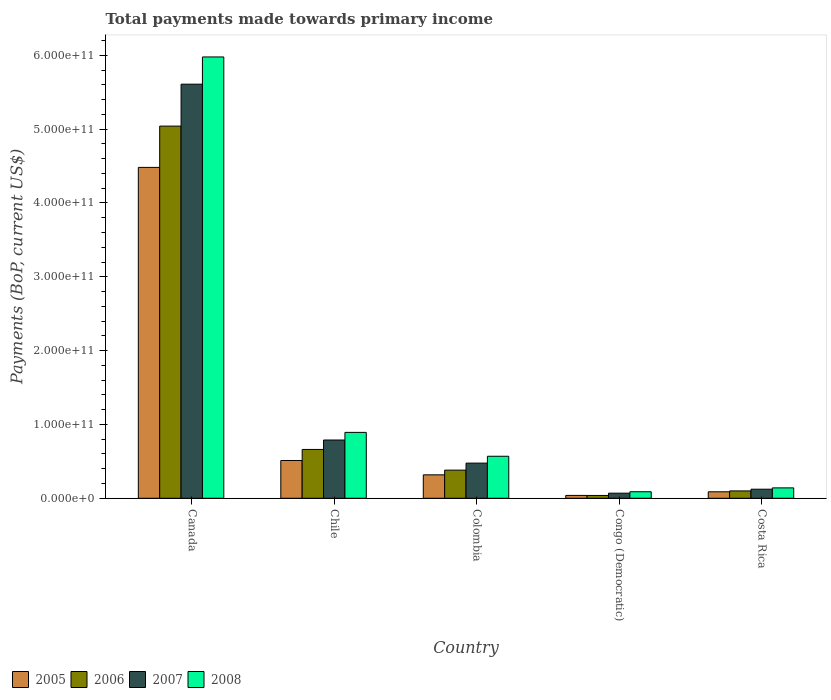How many groups of bars are there?
Provide a succinct answer. 5. Are the number of bars per tick equal to the number of legend labels?
Make the answer very short. Yes. Are the number of bars on each tick of the X-axis equal?
Provide a short and direct response. Yes. In how many cases, is the number of bars for a given country not equal to the number of legend labels?
Provide a succinct answer. 0. What is the total payments made towards primary income in 2007 in Colombia?
Make the answer very short. 4.76e+1. Across all countries, what is the maximum total payments made towards primary income in 2007?
Your answer should be compact. 5.61e+11. Across all countries, what is the minimum total payments made towards primary income in 2005?
Your answer should be compact. 3.89e+09. In which country was the total payments made towards primary income in 2007 minimum?
Keep it short and to the point. Congo (Democratic). What is the total total payments made towards primary income in 2007 in the graph?
Your response must be concise. 7.07e+11. What is the difference between the total payments made towards primary income in 2006 in Canada and that in Colombia?
Give a very brief answer. 4.66e+11. What is the difference between the total payments made towards primary income in 2006 in Costa Rica and the total payments made towards primary income in 2008 in Canada?
Your answer should be very brief. -5.88e+11. What is the average total payments made towards primary income in 2006 per country?
Your response must be concise. 1.24e+11. What is the difference between the total payments made towards primary income of/in 2007 and total payments made towards primary income of/in 2008 in Congo (Democratic)?
Offer a very short reply. -1.96e+09. In how many countries, is the total payments made towards primary income in 2005 greater than 380000000000 US$?
Offer a very short reply. 1. What is the ratio of the total payments made towards primary income in 2006 in Canada to that in Congo (Democratic)?
Ensure brevity in your answer.  131.65. What is the difference between the highest and the second highest total payments made towards primary income in 2005?
Ensure brevity in your answer.  -4.16e+11. What is the difference between the highest and the lowest total payments made towards primary income in 2008?
Make the answer very short. 5.89e+11. What does the 4th bar from the right in Costa Rica represents?
Your answer should be compact. 2005. How many countries are there in the graph?
Ensure brevity in your answer.  5. What is the difference between two consecutive major ticks on the Y-axis?
Make the answer very short. 1.00e+11. Where does the legend appear in the graph?
Your answer should be compact. Bottom left. How are the legend labels stacked?
Your answer should be very brief. Horizontal. What is the title of the graph?
Ensure brevity in your answer.  Total payments made towards primary income. Does "1977" appear as one of the legend labels in the graph?
Offer a terse response. No. What is the label or title of the Y-axis?
Offer a very short reply. Payments (BoP, current US$). What is the Payments (BoP, current US$) in 2005 in Canada?
Offer a terse response. 4.48e+11. What is the Payments (BoP, current US$) in 2006 in Canada?
Keep it short and to the point. 5.04e+11. What is the Payments (BoP, current US$) of 2007 in Canada?
Give a very brief answer. 5.61e+11. What is the Payments (BoP, current US$) in 2008 in Canada?
Your answer should be very brief. 5.98e+11. What is the Payments (BoP, current US$) of 2005 in Chile?
Offer a very short reply. 5.12e+1. What is the Payments (BoP, current US$) of 2006 in Chile?
Give a very brief answer. 6.61e+1. What is the Payments (BoP, current US$) in 2007 in Chile?
Your answer should be very brief. 7.89e+1. What is the Payments (BoP, current US$) in 2008 in Chile?
Your answer should be compact. 8.92e+1. What is the Payments (BoP, current US$) in 2005 in Colombia?
Your response must be concise. 3.18e+1. What is the Payments (BoP, current US$) of 2006 in Colombia?
Offer a very short reply. 3.81e+1. What is the Payments (BoP, current US$) in 2007 in Colombia?
Make the answer very short. 4.76e+1. What is the Payments (BoP, current US$) of 2008 in Colombia?
Ensure brevity in your answer.  5.69e+1. What is the Payments (BoP, current US$) of 2005 in Congo (Democratic)?
Your response must be concise. 3.89e+09. What is the Payments (BoP, current US$) in 2006 in Congo (Democratic)?
Your answer should be compact. 3.83e+09. What is the Payments (BoP, current US$) in 2007 in Congo (Democratic)?
Provide a succinct answer. 6.90e+09. What is the Payments (BoP, current US$) in 2008 in Congo (Democratic)?
Ensure brevity in your answer.  8.86e+09. What is the Payments (BoP, current US$) of 2005 in Costa Rica?
Keep it short and to the point. 8.79e+09. What is the Payments (BoP, current US$) of 2006 in Costa Rica?
Ensure brevity in your answer.  9.98e+09. What is the Payments (BoP, current US$) in 2007 in Costa Rica?
Give a very brief answer. 1.23e+1. What is the Payments (BoP, current US$) in 2008 in Costa Rica?
Ensure brevity in your answer.  1.41e+1. Across all countries, what is the maximum Payments (BoP, current US$) in 2005?
Provide a short and direct response. 4.48e+11. Across all countries, what is the maximum Payments (BoP, current US$) in 2006?
Ensure brevity in your answer.  5.04e+11. Across all countries, what is the maximum Payments (BoP, current US$) of 2007?
Provide a succinct answer. 5.61e+11. Across all countries, what is the maximum Payments (BoP, current US$) of 2008?
Ensure brevity in your answer.  5.98e+11. Across all countries, what is the minimum Payments (BoP, current US$) in 2005?
Make the answer very short. 3.89e+09. Across all countries, what is the minimum Payments (BoP, current US$) in 2006?
Give a very brief answer. 3.83e+09. Across all countries, what is the minimum Payments (BoP, current US$) in 2007?
Make the answer very short. 6.90e+09. Across all countries, what is the minimum Payments (BoP, current US$) in 2008?
Provide a succinct answer. 8.86e+09. What is the total Payments (BoP, current US$) in 2005 in the graph?
Give a very brief answer. 5.44e+11. What is the total Payments (BoP, current US$) in 2006 in the graph?
Give a very brief answer. 6.22e+11. What is the total Payments (BoP, current US$) in 2007 in the graph?
Keep it short and to the point. 7.07e+11. What is the total Payments (BoP, current US$) in 2008 in the graph?
Ensure brevity in your answer.  7.67e+11. What is the difference between the Payments (BoP, current US$) of 2005 in Canada and that in Chile?
Your answer should be compact. 3.97e+11. What is the difference between the Payments (BoP, current US$) of 2006 in Canada and that in Chile?
Make the answer very short. 4.38e+11. What is the difference between the Payments (BoP, current US$) in 2007 in Canada and that in Chile?
Your answer should be very brief. 4.82e+11. What is the difference between the Payments (BoP, current US$) in 2008 in Canada and that in Chile?
Offer a terse response. 5.09e+11. What is the difference between the Payments (BoP, current US$) of 2005 in Canada and that in Colombia?
Ensure brevity in your answer.  4.16e+11. What is the difference between the Payments (BoP, current US$) of 2006 in Canada and that in Colombia?
Your answer should be compact. 4.66e+11. What is the difference between the Payments (BoP, current US$) in 2007 in Canada and that in Colombia?
Your answer should be compact. 5.13e+11. What is the difference between the Payments (BoP, current US$) in 2008 in Canada and that in Colombia?
Keep it short and to the point. 5.41e+11. What is the difference between the Payments (BoP, current US$) in 2005 in Canada and that in Congo (Democratic)?
Ensure brevity in your answer.  4.44e+11. What is the difference between the Payments (BoP, current US$) of 2006 in Canada and that in Congo (Democratic)?
Offer a terse response. 5.00e+11. What is the difference between the Payments (BoP, current US$) in 2007 in Canada and that in Congo (Democratic)?
Offer a terse response. 5.54e+11. What is the difference between the Payments (BoP, current US$) of 2008 in Canada and that in Congo (Democratic)?
Provide a succinct answer. 5.89e+11. What is the difference between the Payments (BoP, current US$) in 2005 in Canada and that in Costa Rica?
Offer a terse response. 4.39e+11. What is the difference between the Payments (BoP, current US$) in 2006 in Canada and that in Costa Rica?
Give a very brief answer. 4.94e+11. What is the difference between the Payments (BoP, current US$) of 2007 in Canada and that in Costa Rica?
Keep it short and to the point. 5.49e+11. What is the difference between the Payments (BoP, current US$) of 2008 in Canada and that in Costa Rica?
Offer a terse response. 5.84e+11. What is the difference between the Payments (BoP, current US$) in 2005 in Chile and that in Colombia?
Ensure brevity in your answer.  1.94e+1. What is the difference between the Payments (BoP, current US$) in 2006 in Chile and that in Colombia?
Keep it short and to the point. 2.80e+1. What is the difference between the Payments (BoP, current US$) of 2007 in Chile and that in Colombia?
Provide a succinct answer. 3.13e+1. What is the difference between the Payments (BoP, current US$) of 2008 in Chile and that in Colombia?
Make the answer very short. 3.23e+1. What is the difference between the Payments (BoP, current US$) in 2005 in Chile and that in Congo (Democratic)?
Give a very brief answer. 4.73e+1. What is the difference between the Payments (BoP, current US$) of 2006 in Chile and that in Congo (Democratic)?
Make the answer very short. 6.23e+1. What is the difference between the Payments (BoP, current US$) in 2007 in Chile and that in Congo (Democratic)?
Offer a very short reply. 7.20e+1. What is the difference between the Payments (BoP, current US$) of 2008 in Chile and that in Congo (Democratic)?
Provide a succinct answer. 8.04e+1. What is the difference between the Payments (BoP, current US$) of 2005 in Chile and that in Costa Rica?
Keep it short and to the point. 4.24e+1. What is the difference between the Payments (BoP, current US$) in 2006 in Chile and that in Costa Rica?
Your answer should be compact. 5.62e+1. What is the difference between the Payments (BoP, current US$) in 2007 in Chile and that in Costa Rica?
Keep it short and to the point. 6.66e+1. What is the difference between the Payments (BoP, current US$) in 2008 in Chile and that in Costa Rica?
Provide a succinct answer. 7.52e+1. What is the difference between the Payments (BoP, current US$) in 2005 in Colombia and that in Congo (Democratic)?
Ensure brevity in your answer.  2.79e+1. What is the difference between the Payments (BoP, current US$) in 2006 in Colombia and that in Congo (Democratic)?
Offer a terse response. 3.43e+1. What is the difference between the Payments (BoP, current US$) of 2007 in Colombia and that in Congo (Democratic)?
Make the answer very short. 4.07e+1. What is the difference between the Payments (BoP, current US$) of 2008 in Colombia and that in Congo (Democratic)?
Offer a terse response. 4.81e+1. What is the difference between the Payments (BoP, current US$) in 2005 in Colombia and that in Costa Rica?
Offer a terse response. 2.30e+1. What is the difference between the Payments (BoP, current US$) of 2006 in Colombia and that in Costa Rica?
Give a very brief answer. 2.81e+1. What is the difference between the Payments (BoP, current US$) of 2007 in Colombia and that in Costa Rica?
Provide a short and direct response. 3.53e+1. What is the difference between the Payments (BoP, current US$) in 2008 in Colombia and that in Costa Rica?
Offer a terse response. 4.28e+1. What is the difference between the Payments (BoP, current US$) in 2005 in Congo (Democratic) and that in Costa Rica?
Offer a very short reply. -4.89e+09. What is the difference between the Payments (BoP, current US$) in 2006 in Congo (Democratic) and that in Costa Rica?
Offer a very short reply. -6.15e+09. What is the difference between the Payments (BoP, current US$) in 2007 in Congo (Democratic) and that in Costa Rica?
Keep it short and to the point. -5.40e+09. What is the difference between the Payments (BoP, current US$) in 2008 in Congo (Democratic) and that in Costa Rica?
Offer a terse response. -5.23e+09. What is the difference between the Payments (BoP, current US$) of 2005 in Canada and the Payments (BoP, current US$) of 2006 in Chile?
Provide a short and direct response. 3.82e+11. What is the difference between the Payments (BoP, current US$) in 2005 in Canada and the Payments (BoP, current US$) in 2007 in Chile?
Give a very brief answer. 3.69e+11. What is the difference between the Payments (BoP, current US$) in 2005 in Canada and the Payments (BoP, current US$) in 2008 in Chile?
Your response must be concise. 3.59e+11. What is the difference between the Payments (BoP, current US$) in 2006 in Canada and the Payments (BoP, current US$) in 2007 in Chile?
Provide a succinct answer. 4.25e+11. What is the difference between the Payments (BoP, current US$) of 2006 in Canada and the Payments (BoP, current US$) of 2008 in Chile?
Make the answer very short. 4.15e+11. What is the difference between the Payments (BoP, current US$) in 2007 in Canada and the Payments (BoP, current US$) in 2008 in Chile?
Offer a terse response. 4.72e+11. What is the difference between the Payments (BoP, current US$) of 2005 in Canada and the Payments (BoP, current US$) of 2006 in Colombia?
Your response must be concise. 4.10e+11. What is the difference between the Payments (BoP, current US$) of 2005 in Canada and the Payments (BoP, current US$) of 2007 in Colombia?
Offer a very short reply. 4.01e+11. What is the difference between the Payments (BoP, current US$) of 2005 in Canada and the Payments (BoP, current US$) of 2008 in Colombia?
Provide a succinct answer. 3.91e+11. What is the difference between the Payments (BoP, current US$) in 2006 in Canada and the Payments (BoP, current US$) in 2007 in Colombia?
Your answer should be compact. 4.56e+11. What is the difference between the Payments (BoP, current US$) of 2006 in Canada and the Payments (BoP, current US$) of 2008 in Colombia?
Give a very brief answer. 4.47e+11. What is the difference between the Payments (BoP, current US$) in 2007 in Canada and the Payments (BoP, current US$) in 2008 in Colombia?
Provide a succinct answer. 5.04e+11. What is the difference between the Payments (BoP, current US$) in 2005 in Canada and the Payments (BoP, current US$) in 2006 in Congo (Democratic)?
Your answer should be very brief. 4.44e+11. What is the difference between the Payments (BoP, current US$) in 2005 in Canada and the Payments (BoP, current US$) in 2007 in Congo (Democratic)?
Provide a succinct answer. 4.41e+11. What is the difference between the Payments (BoP, current US$) of 2005 in Canada and the Payments (BoP, current US$) of 2008 in Congo (Democratic)?
Make the answer very short. 4.39e+11. What is the difference between the Payments (BoP, current US$) of 2006 in Canada and the Payments (BoP, current US$) of 2007 in Congo (Democratic)?
Provide a short and direct response. 4.97e+11. What is the difference between the Payments (BoP, current US$) of 2006 in Canada and the Payments (BoP, current US$) of 2008 in Congo (Democratic)?
Provide a short and direct response. 4.95e+11. What is the difference between the Payments (BoP, current US$) in 2007 in Canada and the Payments (BoP, current US$) in 2008 in Congo (Democratic)?
Make the answer very short. 5.52e+11. What is the difference between the Payments (BoP, current US$) in 2005 in Canada and the Payments (BoP, current US$) in 2006 in Costa Rica?
Offer a very short reply. 4.38e+11. What is the difference between the Payments (BoP, current US$) in 2005 in Canada and the Payments (BoP, current US$) in 2007 in Costa Rica?
Provide a short and direct response. 4.36e+11. What is the difference between the Payments (BoP, current US$) in 2005 in Canada and the Payments (BoP, current US$) in 2008 in Costa Rica?
Make the answer very short. 4.34e+11. What is the difference between the Payments (BoP, current US$) in 2006 in Canada and the Payments (BoP, current US$) in 2007 in Costa Rica?
Offer a terse response. 4.92e+11. What is the difference between the Payments (BoP, current US$) in 2006 in Canada and the Payments (BoP, current US$) in 2008 in Costa Rica?
Your answer should be compact. 4.90e+11. What is the difference between the Payments (BoP, current US$) in 2007 in Canada and the Payments (BoP, current US$) in 2008 in Costa Rica?
Your response must be concise. 5.47e+11. What is the difference between the Payments (BoP, current US$) in 2005 in Chile and the Payments (BoP, current US$) in 2006 in Colombia?
Provide a short and direct response. 1.31e+1. What is the difference between the Payments (BoP, current US$) of 2005 in Chile and the Payments (BoP, current US$) of 2007 in Colombia?
Make the answer very short. 3.56e+09. What is the difference between the Payments (BoP, current US$) of 2005 in Chile and the Payments (BoP, current US$) of 2008 in Colombia?
Your response must be concise. -5.74e+09. What is the difference between the Payments (BoP, current US$) in 2006 in Chile and the Payments (BoP, current US$) in 2007 in Colombia?
Your response must be concise. 1.85e+1. What is the difference between the Payments (BoP, current US$) of 2006 in Chile and the Payments (BoP, current US$) of 2008 in Colombia?
Your answer should be very brief. 9.21e+09. What is the difference between the Payments (BoP, current US$) of 2007 in Chile and the Payments (BoP, current US$) of 2008 in Colombia?
Keep it short and to the point. 2.20e+1. What is the difference between the Payments (BoP, current US$) of 2005 in Chile and the Payments (BoP, current US$) of 2006 in Congo (Democratic)?
Make the answer very short. 4.74e+1. What is the difference between the Payments (BoP, current US$) of 2005 in Chile and the Payments (BoP, current US$) of 2007 in Congo (Democratic)?
Ensure brevity in your answer.  4.43e+1. What is the difference between the Payments (BoP, current US$) in 2005 in Chile and the Payments (BoP, current US$) in 2008 in Congo (Democratic)?
Your response must be concise. 4.23e+1. What is the difference between the Payments (BoP, current US$) in 2006 in Chile and the Payments (BoP, current US$) in 2007 in Congo (Democratic)?
Your response must be concise. 5.92e+1. What is the difference between the Payments (BoP, current US$) of 2006 in Chile and the Payments (BoP, current US$) of 2008 in Congo (Democratic)?
Your answer should be very brief. 5.73e+1. What is the difference between the Payments (BoP, current US$) of 2007 in Chile and the Payments (BoP, current US$) of 2008 in Congo (Democratic)?
Your response must be concise. 7.01e+1. What is the difference between the Payments (BoP, current US$) in 2005 in Chile and the Payments (BoP, current US$) in 2006 in Costa Rica?
Offer a very short reply. 4.12e+1. What is the difference between the Payments (BoP, current US$) in 2005 in Chile and the Payments (BoP, current US$) in 2007 in Costa Rica?
Ensure brevity in your answer.  3.89e+1. What is the difference between the Payments (BoP, current US$) in 2005 in Chile and the Payments (BoP, current US$) in 2008 in Costa Rica?
Give a very brief answer. 3.71e+1. What is the difference between the Payments (BoP, current US$) in 2006 in Chile and the Payments (BoP, current US$) in 2007 in Costa Rica?
Provide a short and direct response. 5.38e+1. What is the difference between the Payments (BoP, current US$) in 2006 in Chile and the Payments (BoP, current US$) in 2008 in Costa Rica?
Give a very brief answer. 5.20e+1. What is the difference between the Payments (BoP, current US$) in 2007 in Chile and the Payments (BoP, current US$) in 2008 in Costa Rica?
Keep it short and to the point. 6.48e+1. What is the difference between the Payments (BoP, current US$) of 2005 in Colombia and the Payments (BoP, current US$) of 2006 in Congo (Democratic)?
Ensure brevity in your answer.  2.79e+1. What is the difference between the Payments (BoP, current US$) in 2005 in Colombia and the Payments (BoP, current US$) in 2007 in Congo (Democratic)?
Your answer should be very brief. 2.49e+1. What is the difference between the Payments (BoP, current US$) in 2005 in Colombia and the Payments (BoP, current US$) in 2008 in Congo (Democratic)?
Your answer should be very brief. 2.29e+1. What is the difference between the Payments (BoP, current US$) of 2006 in Colombia and the Payments (BoP, current US$) of 2007 in Congo (Democratic)?
Your response must be concise. 3.12e+1. What is the difference between the Payments (BoP, current US$) in 2006 in Colombia and the Payments (BoP, current US$) in 2008 in Congo (Democratic)?
Your answer should be very brief. 2.93e+1. What is the difference between the Payments (BoP, current US$) in 2007 in Colombia and the Payments (BoP, current US$) in 2008 in Congo (Democratic)?
Make the answer very short. 3.88e+1. What is the difference between the Payments (BoP, current US$) in 2005 in Colombia and the Payments (BoP, current US$) in 2006 in Costa Rica?
Make the answer very short. 2.18e+1. What is the difference between the Payments (BoP, current US$) in 2005 in Colombia and the Payments (BoP, current US$) in 2007 in Costa Rica?
Provide a succinct answer. 1.95e+1. What is the difference between the Payments (BoP, current US$) in 2005 in Colombia and the Payments (BoP, current US$) in 2008 in Costa Rica?
Your response must be concise. 1.77e+1. What is the difference between the Payments (BoP, current US$) of 2006 in Colombia and the Payments (BoP, current US$) of 2007 in Costa Rica?
Make the answer very short. 2.58e+1. What is the difference between the Payments (BoP, current US$) in 2006 in Colombia and the Payments (BoP, current US$) in 2008 in Costa Rica?
Keep it short and to the point. 2.40e+1. What is the difference between the Payments (BoP, current US$) in 2007 in Colombia and the Payments (BoP, current US$) in 2008 in Costa Rica?
Your answer should be very brief. 3.35e+1. What is the difference between the Payments (BoP, current US$) in 2005 in Congo (Democratic) and the Payments (BoP, current US$) in 2006 in Costa Rica?
Ensure brevity in your answer.  -6.08e+09. What is the difference between the Payments (BoP, current US$) of 2005 in Congo (Democratic) and the Payments (BoP, current US$) of 2007 in Costa Rica?
Provide a short and direct response. -8.41e+09. What is the difference between the Payments (BoP, current US$) in 2005 in Congo (Democratic) and the Payments (BoP, current US$) in 2008 in Costa Rica?
Your answer should be compact. -1.02e+1. What is the difference between the Payments (BoP, current US$) of 2006 in Congo (Democratic) and the Payments (BoP, current US$) of 2007 in Costa Rica?
Offer a very short reply. -8.47e+09. What is the difference between the Payments (BoP, current US$) of 2006 in Congo (Democratic) and the Payments (BoP, current US$) of 2008 in Costa Rica?
Your response must be concise. -1.03e+1. What is the difference between the Payments (BoP, current US$) in 2007 in Congo (Democratic) and the Payments (BoP, current US$) in 2008 in Costa Rica?
Your answer should be compact. -7.19e+09. What is the average Payments (BoP, current US$) of 2005 per country?
Give a very brief answer. 1.09e+11. What is the average Payments (BoP, current US$) of 2006 per country?
Ensure brevity in your answer.  1.24e+11. What is the average Payments (BoP, current US$) of 2007 per country?
Ensure brevity in your answer.  1.41e+11. What is the average Payments (BoP, current US$) in 2008 per country?
Ensure brevity in your answer.  1.53e+11. What is the difference between the Payments (BoP, current US$) of 2005 and Payments (BoP, current US$) of 2006 in Canada?
Keep it short and to the point. -5.59e+1. What is the difference between the Payments (BoP, current US$) in 2005 and Payments (BoP, current US$) in 2007 in Canada?
Provide a succinct answer. -1.13e+11. What is the difference between the Payments (BoP, current US$) in 2005 and Payments (BoP, current US$) in 2008 in Canada?
Provide a short and direct response. -1.50e+11. What is the difference between the Payments (BoP, current US$) of 2006 and Payments (BoP, current US$) of 2007 in Canada?
Ensure brevity in your answer.  -5.68e+1. What is the difference between the Payments (BoP, current US$) of 2006 and Payments (BoP, current US$) of 2008 in Canada?
Your response must be concise. -9.37e+1. What is the difference between the Payments (BoP, current US$) of 2007 and Payments (BoP, current US$) of 2008 in Canada?
Ensure brevity in your answer.  -3.69e+1. What is the difference between the Payments (BoP, current US$) of 2005 and Payments (BoP, current US$) of 2006 in Chile?
Offer a terse response. -1.49e+1. What is the difference between the Payments (BoP, current US$) in 2005 and Payments (BoP, current US$) in 2007 in Chile?
Your answer should be compact. -2.77e+1. What is the difference between the Payments (BoP, current US$) of 2005 and Payments (BoP, current US$) of 2008 in Chile?
Offer a very short reply. -3.81e+1. What is the difference between the Payments (BoP, current US$) in 2006 and Payments (BoP, current US$) in 2007 in Chile?
Ensure brevity in your answer.  -1.28e+1. What is the difference between the Payments (BoP, current US$) of 2006 and Payments (BoP, current US$) of 2008 in Chile?
Provide a succinct answer. -2.31e+1. What is the difference between the Payments (BoP, current US$) of 2007 and Payments (BoP, current US$) of 2008 in Chile?
Provide a succinct answer. -1.03e+1. What is the difference between the Payments (BoP, current US$) in 2005 and Payments (BoP, current US$) in 2006 in Colombia?
Provide a short and direct response. -6.36e+09. What is the difference between the Payments (BoP, current US$) of 2005 and Payments (BoP, current US$) of 2007 in Colombia?
Your answer should be very brief. -1.59e+1. What is the difference between the Payments (BoP, current US$) of 2005 and Payments (BoP, current US$) of 2008 in Colombia?
Offer a very short reply. -2.52e+1. What is the difference between the Payments (BoP, current US$) of 2006 and Payments (BoP, current US$) of 2007 in Colombia?
Provide a short and direct response. -9.51e+09. What is the difference between the Payments (BoP, current US$) of 2006 and Payments (BoP, current US$) of 2008 in Colombia?
Provide a succinct answer. -1.88e+1. What is the difference between the Payments (BoP, current US$) of 2007 and Payments (BoP, current US$) of 2008 in Colombia?
Your response must be concise. -9.30e+09. What is the difference between the Payments (BoP, current US$) in 2005 and Payments (BoP, current US$) in 2006 in Congo (Democratic)?
Your answer should be compact. 6.30e+07. What is the difference between the Payments (BoP, current US$) in 2005 and Payments (BoP, current US$) in 2007 in Congo (Democratic)?
Your answer should be very brief. -3.01e+09. What is the difference between the Payments (BoP, current US$) of 2005 and Payments (BoP, current US$) of 2008 in Congo (Democratic)?
Offer a terse response. -4.97e+09. What is the difference between the Payments (BoP, current US$) in 2006 and Payments (BoP, current US$) in 2007 in Congo (Democratic)?
Provide a succinct answer. -3.07e+09. What is the difference between the Payments (BoP, current US$) in 2006 and Payments (BoP, current US$) in 2008 in Congo (Democratic)?
Give a very brief answer. -5.03e+09. What is the difference between the Payments (BoP, current US$) of 2007 and Payments (BoP, current US$) of 2008 in Congo (Democratic)?
Give a very brief answer. -1.96e+09. What is the difference between the Payments (BoP, current US$) in 2005 and Payments (BoP, current US$) in 2006 in Costa Rica?
Offer a very short reply. -1.19e+09. What is the difference between the Payments (BoP, current US$) of 2005 and Payments (BoP, current US$) of 2007 in Costa Rica?
Provide a succinct answer. -3.51e+09. What is the difference between the Payments (BoP, current US$) in 2005 and Payments (BoP, current US$) in 2008 in Costa Rica?
Your response must be concise. -5.31e+09. What is the difference between the Payments (BoP, current US$) of 2006 and Payments (BoP, current US$) of 2007 in Costa Rica?
Offer a very short reply. -2.32e+09. What is the difference between the Payments (BoP, current US$) of 2006 and Payments (BoP, current US$) of 2008 in Costa Rica?
Your answer should be very brief. -4.12e+09. What is the difference between the Payments (BoP, current US$) of 2007 and Payments (BoP, current US$) of 2008 in Costa Rica?
Provide a short and direct response. -1.79e+09. What is the ratio of the Payments (BoP, current US$) of 2005 in Canada to that in Chile?
Offer a very short reply. 8.76. What is the ratio of the Payments (BoP, current US$) in 2006 in Canada to that in Chile?
Your response must be concise. 7.62. What is the ratio of the Payments (BoP, current US$) in 2007 in Canada to that in Chile?
Provide a short and direct response. 7.11. What is the ratio of the Payments (BoP, current US$) in 2008 in Canada to that in Chile?
Your response must be concise. 6.7. What is the ratio of the Payments (BoP, current US$) in 2005 in Canada to that in Colombia?
Make the answer very short. 14.11. What is the ratio of the Payments (BoP, current US$) of 2006 in Canada to that in Colombia?
Keep it short and to the point. 13.22. What is the ratio of the Payments (BoP, current US$) of 2007 in Canada to that in Colombia?
Offer a terse response. 11.78. What is the ratio of the Payments (BoP, current US$) in 2008 in Canada to that in Colombia?
Keep it short and to the point. 10.5. What is the ratio of the Payments (BoP, current US$) in 2005 in Canada to that in Congo (Democratic)?
Make the answer very short. 115.15. What is the ratio of the Payments (BoP, current US$) of 2006 in Canada to that in Congo (Democratic)?
Provide a short and direct response. 131.65. What is the ratio of the Payments (BoP, current US$) in 2007 in Canada to that in Congo (Democratic)?
Give a very brief answer. 81.27. What is the ratio of the Payments (BoP, current US$) of 2008 in Canada to that in Congo (Democratic)?
Keep it short and to the point. 67.45. What is the ratio of the Payments (BoP, current US$) of 2005 in Canada to that in Costa Rica?
Keep it short and to the point. 51. What is the ratio of the Payments (BoP, current US$) of 2006 in Canada to that in Costa Rica?
Your answer should be very brief. 50.53. What is the ratio of the Payments (BoP, current US$) in 2007 in Canada to that in Costa Rica?
Make the answer very short. 45.6. What is the ratio of the Payments (BoP, current US$) in 2008 in Canada to that in Costa Rica?
Offer a very short reply. 42.42. What is the ratio of the Payments (BoP, current US$) in 2005 in Chile to that in Colombia?
Your answer should be very brief. 1.61. What is the ratio of the Payments (BoP, current US$) in 2006 in Chile to that in Colombia?
Give a very brief answer. 1.74. What is the ratio of the Payments (BoP, current US$) in 2007 in Chile to that in Colombia?
Your answer should be very brief. 1.66. What is the ratio of the Payments (BoP, current US$) of 2008 in Chile to that in Colombia?
Ensure brevity in your answer.  1.57. What is the ratio of the Payments (BoP, current US$) in 2005 in Chile to that in Congo (Democratic)?
Offer a very short reply. 13.15. What is the ratio of the Payments (BoP, current US$) in 2006 in Chile to that in Congo (Democratic)?
Your answer should be very brief. 17.27. What is the ratio of the Payments (BoP, current US$) of 2007 in Chile to that in Congo (Democratic)?
Provide a succinct answer. 11.44. What is the ratio of the Payments (BoP, current US$) in 2008 in Chile to that in Congo (Democratic)?
Offer a terse response. 10.07. What is the ratio of the Payments (BoP, current US$) of 2005 in Chile to that in Costa Rica?
Your answer should be compact. 5.83. What is the ratio of the Payments (BoP, current US$) of 2006 in Chile to that in Costa Rica?
Give a very brief answer. 6.63. What is the ratio of the Payments (BoP, current US$) of 2007 in Chile to that in Costa Rica?
Offer a very short reply. 6.42. What is the ratio of the Payments (BoP, current US$) of 2008 in Chile to that in Costa Rica?
Make the answer very short. 6.33. What is the ratio of the Payments (BoP, current US$) in 2005 in Colombia to that in Congo (Democratic)?
Ensure brevity in your answer.  8.16. What is the ratio of the Payments (BoP, current US$) of 2006 in Colombia to that in Congo (Democratic)?
Your answer should be compact. 9.96. What is the ratio of the Payments (BoP, current US$) of 2007 in Colombia to that in Congo (Democratic)?
Give a very brief answer. 6.9. What is the ratio of the Payments (BoP, current US$) of 2008 in Colombia to that in Congo (Democratic)?
Ensure brevity in your answer.  6.42. What is the ratio of the Payments (BoP, current US$) of 2005 in Colombia to that in Costa Rica?
Your answer should be very brief. 3.61. What is the ratio of the Payments (BoP, current US$) in 2006 in Colombia to that in Costa Rica?
Offer a very short reply. 3.82. What is the ratio of the Payments (BoP, current US$) of 2007 in Colombia to that in Costa Rica?
Provide a succinct answer. 3.87. What is the ratio of the Payments (BoP, current US$) of 2008 in Colombia to that in Costa Rica?
Your answer should be very brief. 4.04. What is the ratio of the Payments (BoP, current US$) in 2005 in Congo (Democratic) to that in Costa Rica?
Give a very brief answer. 0.44. What is the ratio of the Payments (BoP, current US$) in 2006 in Congo (Democratic) to that in Costa Rica?
Provide a short and direct response. 0.38. What is the ratio of the Payments (BoP, current US$) of 2007 in Congo (Democratic) to that in Costa Rica?
Offer a terse response. 0.56. What is the ratio of the Payments (BoP, current US$) of 2008 in Congo (Democratic) to that in Costa Rica?
Keep it short and to the point. 0.63. What is the difference between the highest and the second highest Payments (BoP, current US$) of 2005?
Offer a very short reply. 3.97e+11. What is the difference between the highest and the second highest Payments (BoP, current US$) in 2006?
Offer a very short reply. 4.38e+11. What is the difference between the highest and the second highest Payments (BoP, current US$) in 2007?
Your response must be concise. 4.82e+11. What is the difference between the highest and the second highest Payments (BoP, current US$) of 2008?
Provide a short and direct response. 5.09e+11. What is the difference between the highest and the lowest Payments (BoP, current US$) in 2005?
Offer a terse response. 4.44e+11. What is the difference between the highest and the lowest Payments (BoP, current US$) in 2006?
Offer a very short reply. 5.00e+11. What is the difference between the highest and the lowest Payments (BoP, current US$) in 2007?
Offer a terse response. 5.54e+11. What is the difference between the highest and the lowest Payments (BoP, current US$) in 2008?
Offer a terse response. 5.89e+11. 